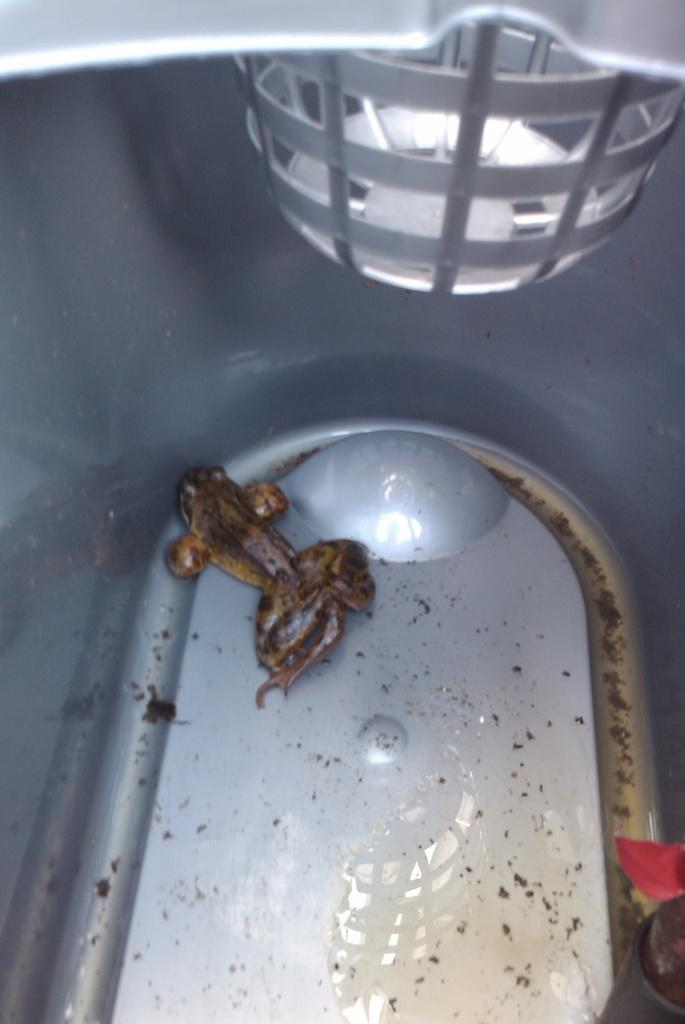What object might be present in the image? There might be a plastic tub in the image. Is there any living creature on the plastic tub? There might be a frog on the plastic tub. What can be seen at the top of the image? There might be a light at the top of the image. Can you hear a whistle in the image? There is no mention of a whistle in the image, so it cannot be heard. Is there a swing present in the image? There is no mention of a swing in the image, so it is not present. 